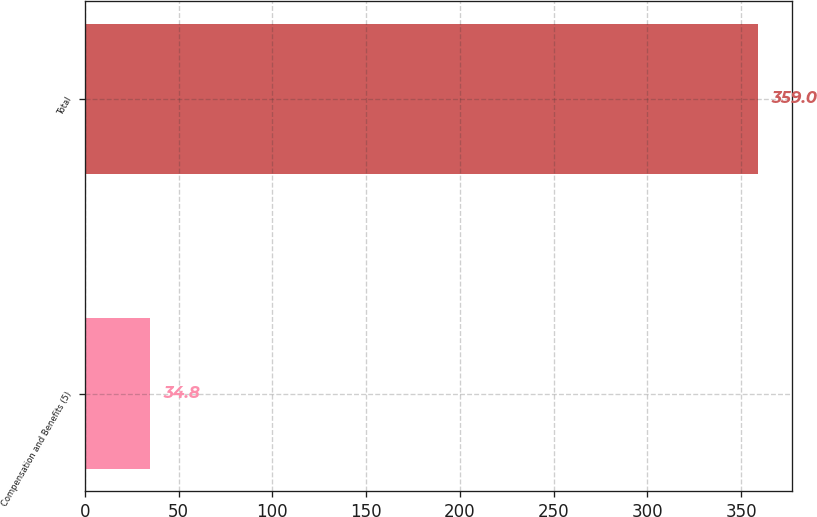<chart> <loc_0><loc_0><loc_500><loc_500><bar_chart><fcel>Compensation and Benefits (5)<fcel>Total<nl><fcel>34.8<fcel>359<nl></chart> 